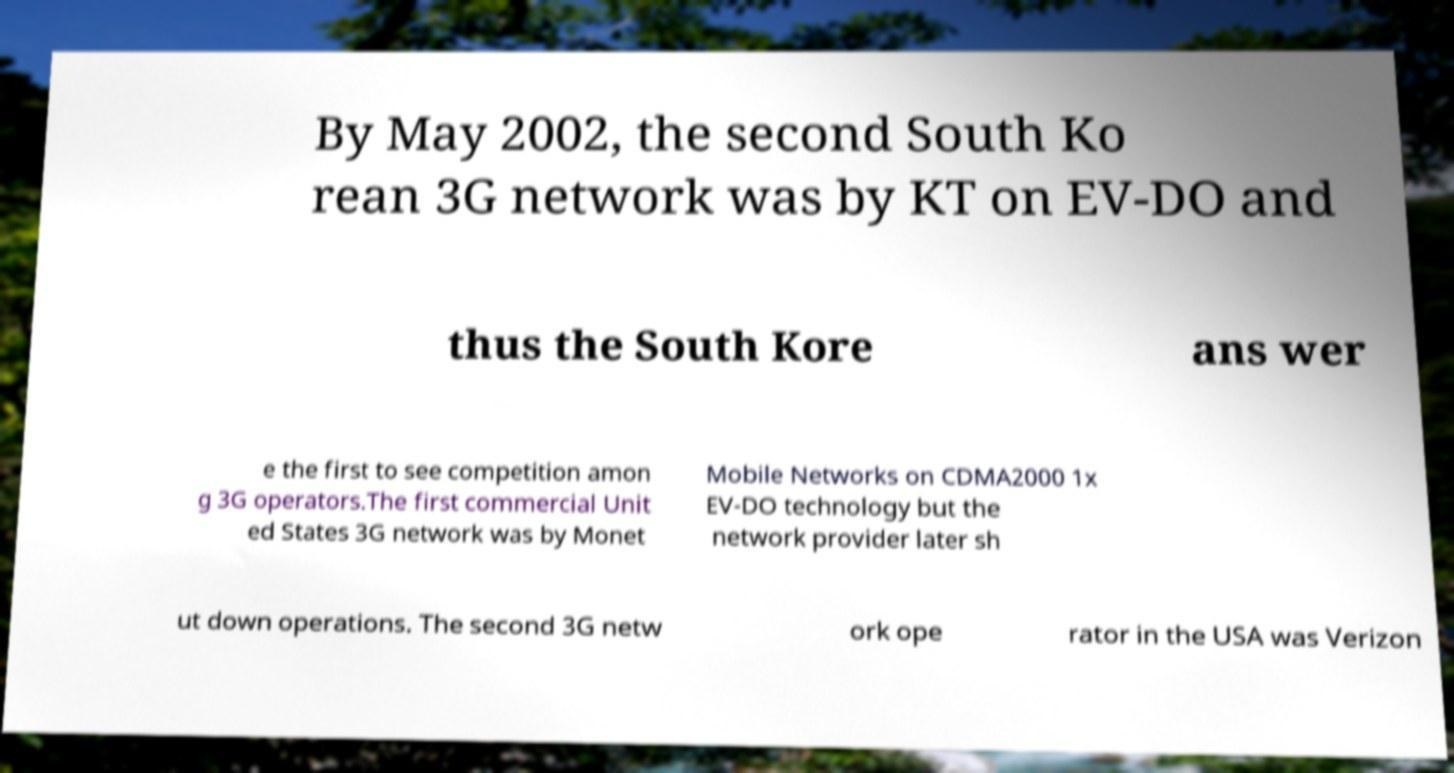For documentation purposes, I need the text within this image transcribed. Could you provide that? By May 2002, the second South Ko rean 3G network was by KT on EV-DO and thus the South Kore ans wer e the first to see competition amon g 3G operators.The first commercial Unit ed States 3G network was by Monet Mobile Networks on CDMA2000 1x EV-DO technology but the network provider later sh ut down operations. The second 3G netw ork ope rator in the USA was Verizon 